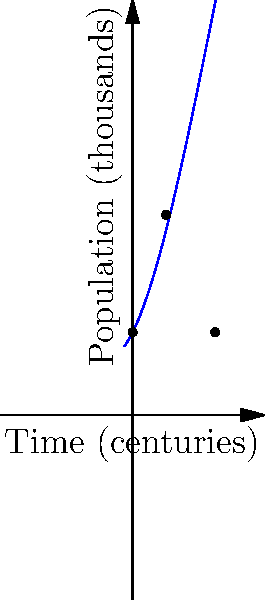Consider the polynomial function $f(x) = -0.01x^3 + 0.3x^2 + 2x + 10$ representing the population growth (in thousands) of ancient Japanese cities over time (in centuries). What does the x-intercept of the rightmost root signify in the context of ancient Japanese urban development, and how might this challenge modern interpretations of Japan's historical urbanization? To answer this question, let's analyze the polynomial function step-by-step:

1) The function $f(x) = -0.01x^3 + 0.3x^2 + 2x + 10$ represents population growth over time.

2) The y-intercept (10) represents the initial population of 10,000.

3) The roots of the polynomial can be found by setting $f(x) = 0$. We can see from the graph that there are two positive roots.

4) The rightmost root occurs at approximately x = 9.96 centuries (or about 996 years) after the initial time.

5) This x-intercept signifies the time when the population returns to its initial value of 10,000 after a period of growth and decline.

6) In the context of ancient Japanese urban development, this suggests a cycle of growth, peak, and decline spanning nearly a millennium.

7) This challenges modern interpretations in several ways:
   a) It implies a much longer period of sustained urban development than often assumed.
   b) It suggests that ancient Japanese cities experienced complex, non-linear growth patterns.
   c) It indicates that some ancient Japanese cities may have had periods of decline as significant as their growth.

8) This model contradicts simplistic views of steady progress or sudden collapse, suggesting instead a nuanced, cyclical pattern of urban development in ancient Japan.
Answer: The rightmost root (x ≈ 9.96) signifies the end of a millennium-long urban cycle, challenging linear growth narratives in Japanese history. 